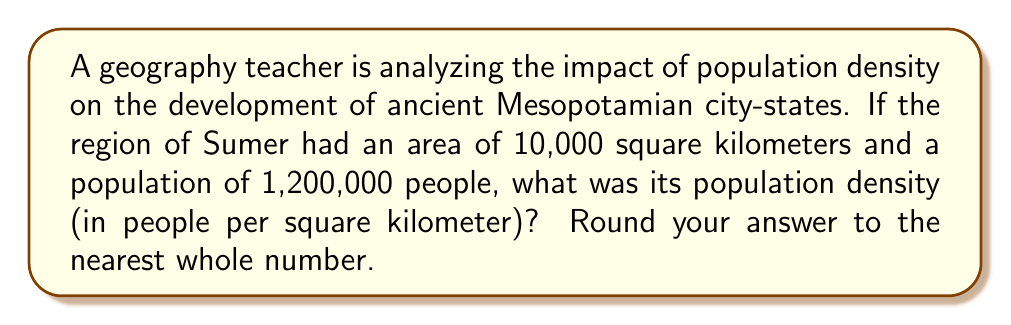Solve this math problem. To solve this problem, we'll follow these steps:

1. Recall the formula for population density:
   $$ \text{Population Density} = \frac{\text{Total Population}}{\text{Total Area}} $$

2. Identify the given information:
   - Total Area: 10,000 square kilometers
   - Total Population: 1,200,000 people

3. Substitute the values into the formula:
   $$ \text{Population Density} = \frac{1,200,000 \text{ people}}{10,000 \text{ km}^2} $$

4. Perform the division:
   $$ \text{Population Density} = 120 \text{ people/km}^2 $$

5. Round to the nearest whole number:
   The result is already a whole number, so no rounding is necessary.

This population density would have significantly influenced the development of Sumerian city-states, affecting factors such as resource distribution, urban planning, and social organization.
Answer: 120 people/km² 